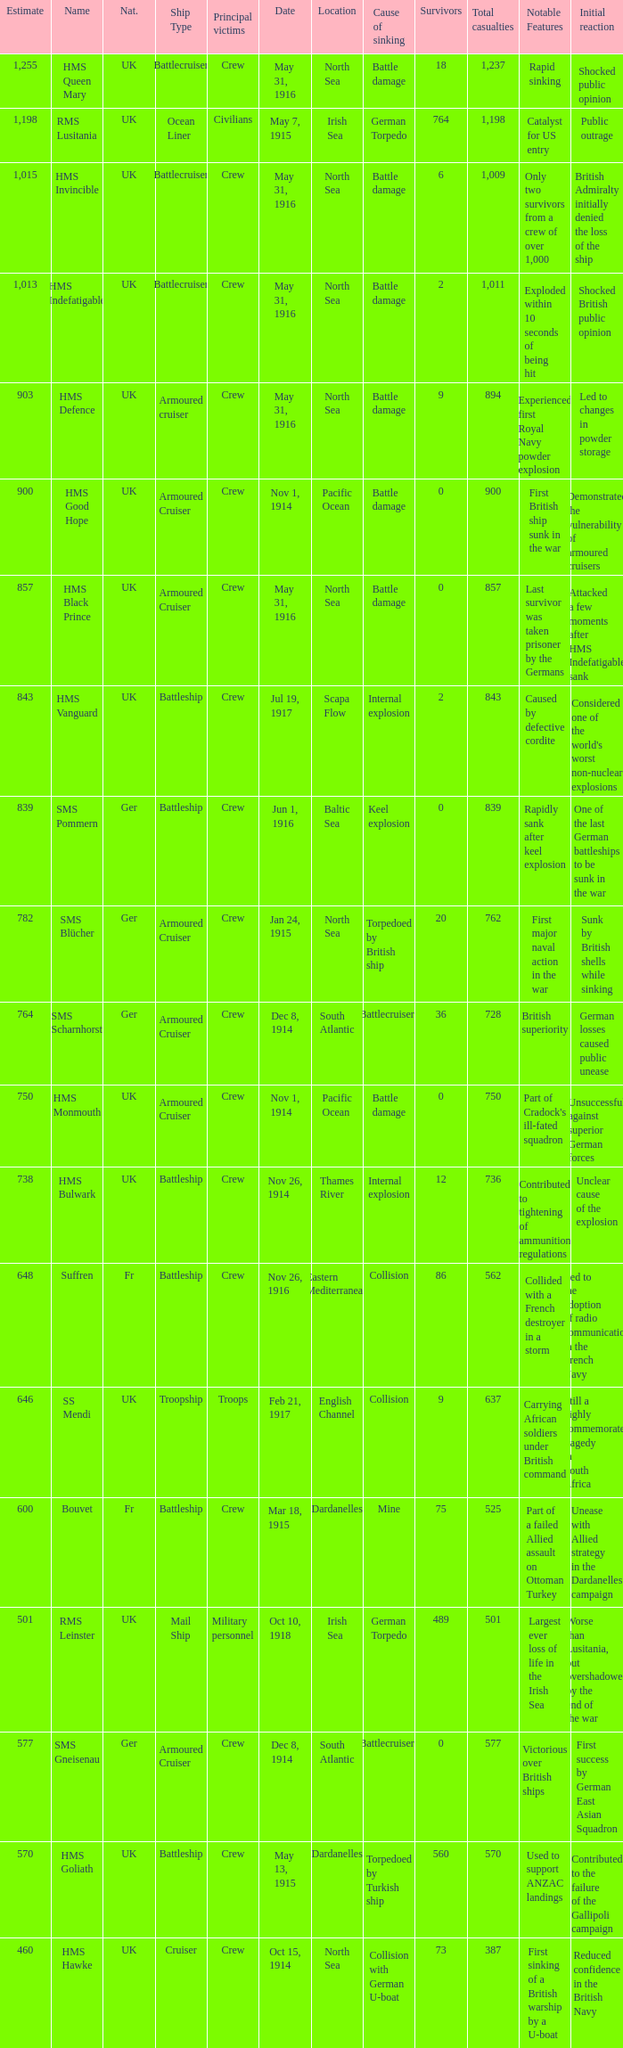What is the nationality of the ship when the principle victims are civilians? UK. Would you be able to parse every entry in this table? {'header': ['Estimate', 'Name', 'Nat.', 'Ship Type', 'Principal victims', 'Date', 'Location', 'Cause of sinking', 'Survivors', 'Total casualties', 'Notable Features', 'Initial reaction'], 'rows': [['1,255', 'HMS Queen Mary', 'UK', 'Battlecruiser', 'Crew', 'May 31, 1916', 'North Sea', 'Battle damage', '18', '1,237', 'Rapid sinking', 'Shocked public opinion'], ['1,198', 'RMS Lusitania', 'UK', 'Ocean Liner', 'Civilians', 'May 7, 1915', 'Irish Sea', 'German Torpedo', '764', '1,198', 'Catalyst for US entry', 'Public outrage'], ['1,015', 'HMS Invincible', 'UK', 'Battlecruiser', 'Crew', 'May 31, 1916', 'North Sea', 'Battle damage', '6', '1,009', 'Only two survivors from a crew of over 1,000', 'British Admiralty initially denied the loss of the ship'], ['1,013', 'HMS Indefatigable', 'UK', 'Battlecruiser', 'Crew', 'May 31, 1916', 'North Sea', 'Battle damage', '2', '1,011', 'Exploded within 10 seconds of being hit', 'Shocked British public opinion'], ['903', 'HMS Defence', 'UK', 'Armoured cruiser', 'Crew', 'May 31, 1916', 'North Sea', 'Battle damage', '9', '894', 'Experienced first Royal Navy powder explosion', 'Led to changes in powder storage'], ['900', 'HMS Good Hope', 'UK', 'Armoured Cruiser', 'Crew', 'Nov 1, 1914', 'Pacific Ocean', 'Battle damage', '0', '900', 'First British ship sunk in the war', 'Demonstrated the vulnerability of armoured cruisers'], ['857', 'HMS Black Prince', 'UK', 'Armoured Cruiser', 'Crew', 'May 31, 1916', 'North Sea', 'Battle damage', '0', '857', 'Last survivor was taken prisoner by the Germans', 'Attacked a few moments after HMS Indefatigable sank'], ['843', 'HMS Vanguard', 'UK', 'Battleship', 'Crew', 'Jul 19, 1917', 'Scapa Flow', 'Internal explosion', '2', '843', 'Caused by defective cordite', "Considered one of the world's worst non-nuclear explosions"], ['839', 'SMS Pommern', 'Ger', 'Battleship', 'Crew', 'Jun 1, 1916', 'Baltic Sea', 'Keel explosion', '0', '839', 'Rapidly sank after keel explosion', 'One of the last German battleships to be sunk in the war'], ['782', 'SMS Blücher', 'Ger', 'Armoured Cruiser', 'Crew', 'Jan 24, 1915', 'North Sea', 'Torpedoed by British ship', '20', '762', 'First major naval action in the war', 'Sunk by British shells while sinking'], ['764', 'SMS Scharnhorst', 'Ger', 'Armoured Cruiser', 'Crew', 'Dec 8, 1914', 'South Atlantic', 'Battlecruisers', '36', '728', 'British superiority', 'German losses caused public unease'], ['750', 'HMS Monmouth', 'UK', 'Armoured Cruiser', 'Crew', 'Nov 1, 1914', 'Pacific Ocean', 'Battle damage', '0', '750', "Part of Cradock's ill-fated squadron", 'Unsuccessful against superior German forces'], ['738', 'HMS Bulwark', 'UK', 'Battleship', 'Crew', 'Nov 26, 1914', 'Thames River', 'Internal explosion', '12', '736', 'Contributed to tightening of ammunition regulations', 'Unclear cause of the explosion'], ['648', 'Suffren', 'Fr', 'Battleship', 'Crew', 'Nov 26, 1916', 'Eastern Mediterranean', 'Collision', '86', '562', 'Collided with a French destroyer in a storm', 'Led to the adoption of radio communication in the French Navy'], ['646', 'SS Mendi', 'UK', 'Troopship', 'Troops', 'Feb 21, 1917', 'English Channel', 'Collision', '9', '637', 'Carrying African soldiers under British command', 'Still a highly commemorated tragedy in South Africa'], ['600', 'Bouvet', 'Fr', 'Battleship', 'Crew', 'Mar 18, 1915', 'Dardanelles', 'Mine', '75', '525', 'Part of a failed Allied assault on Ottoman Turkey', 'Unease with Allied strategy in the Dardanelles campaign'], ['501', 'RMS Leinster', 'UK', 'Mail Ship', 'Military personnel', 'Oct 10, 1918', 'Irish Sea', 'German Torpedo', '489', '501', 'Largest ever loss of life in the Irish Sea', 'Worse than Lusitania, but overshadowed by the end of the war'], ['577', 'SMS Gneisenau', 'Ger', 'Armoured Cruiser', 'Crew', 'Dec 8, 1914', 'South Atlantic', 'Battlecruisers', '0', '577', 'Victorious over British ships', 'First success by German East Asian Squadron'], ['570', 'HMS Goliath', 'UK', 'Battleship', 'Crew', 'May 13, 1915', 'Dardanelles', 'Torpedoed by Turkish ship', '560', '570', 'Used to support ANZAC landings', 'Contributed to the failure of the Gallipoli campaign'], ['460', 'HMS Hawke', 'UK', 'Cruiser', 'Crew', 'Oct 15, 1914', 'North Sea', 'Collision with German U-boat', '73', '387', 'First sinking of a British warship by a U-boat', 'Reduced confidence in the British Navy']]} 